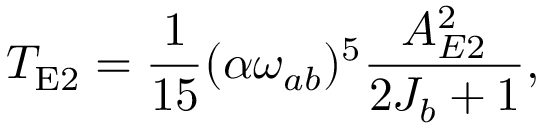Convert formula to latex. <formula><loc_0><loc_0><loc_500><loc_500>T _ { E 2 } = \frac { 1 } { 1 5 } ( \alpha \omega _ { a b } ) ^ { 5 } \frac { A _ { E 2 } ^ { 2 } } { 2 J _ { b } + 1 } ,</formula> 